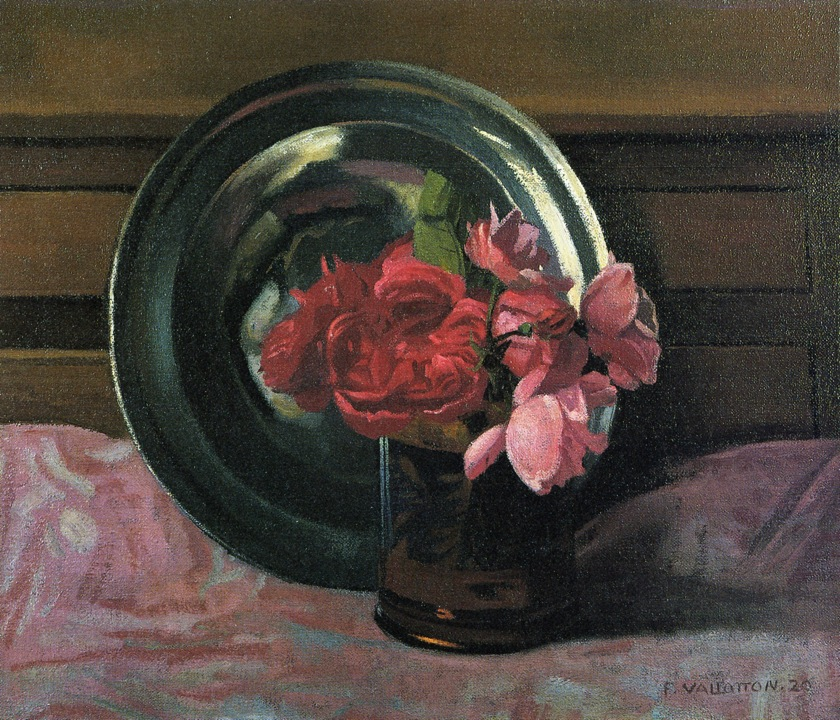What might the green plate symbolize in this painting? The green plate in the painting can be interpreted as a symbol of stability and grounding amidst the vibrant, transient beauty of the roses. The green hue often represents growth, renewal, and life, providing a subtle contrast to the more striking colors of the flowers. The plate's round shape adds a sense of harmony and balance to the composition, perhaps hinting at the cyclical nature of life and nature's continuous renewal. It acts as a silent guardian of the beauty before it, reminding the viewer of the constant yet gentle backdrop of nature that supports and frames moments of splendor. 